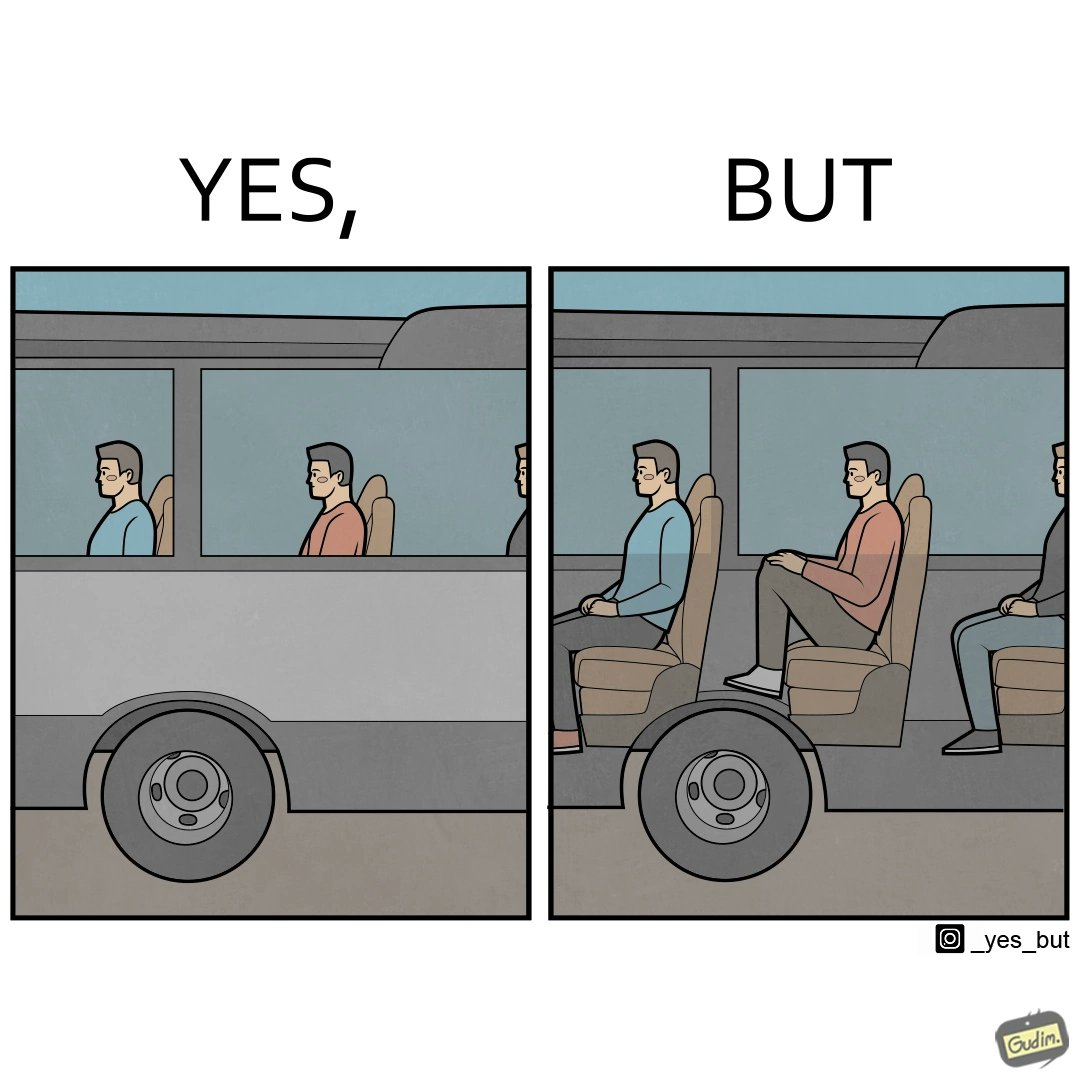Compare the left and right sides of this image. In the left part of the image: people traveling on the bus In the right part of the image: a person sitting uncomfortably on a bus 